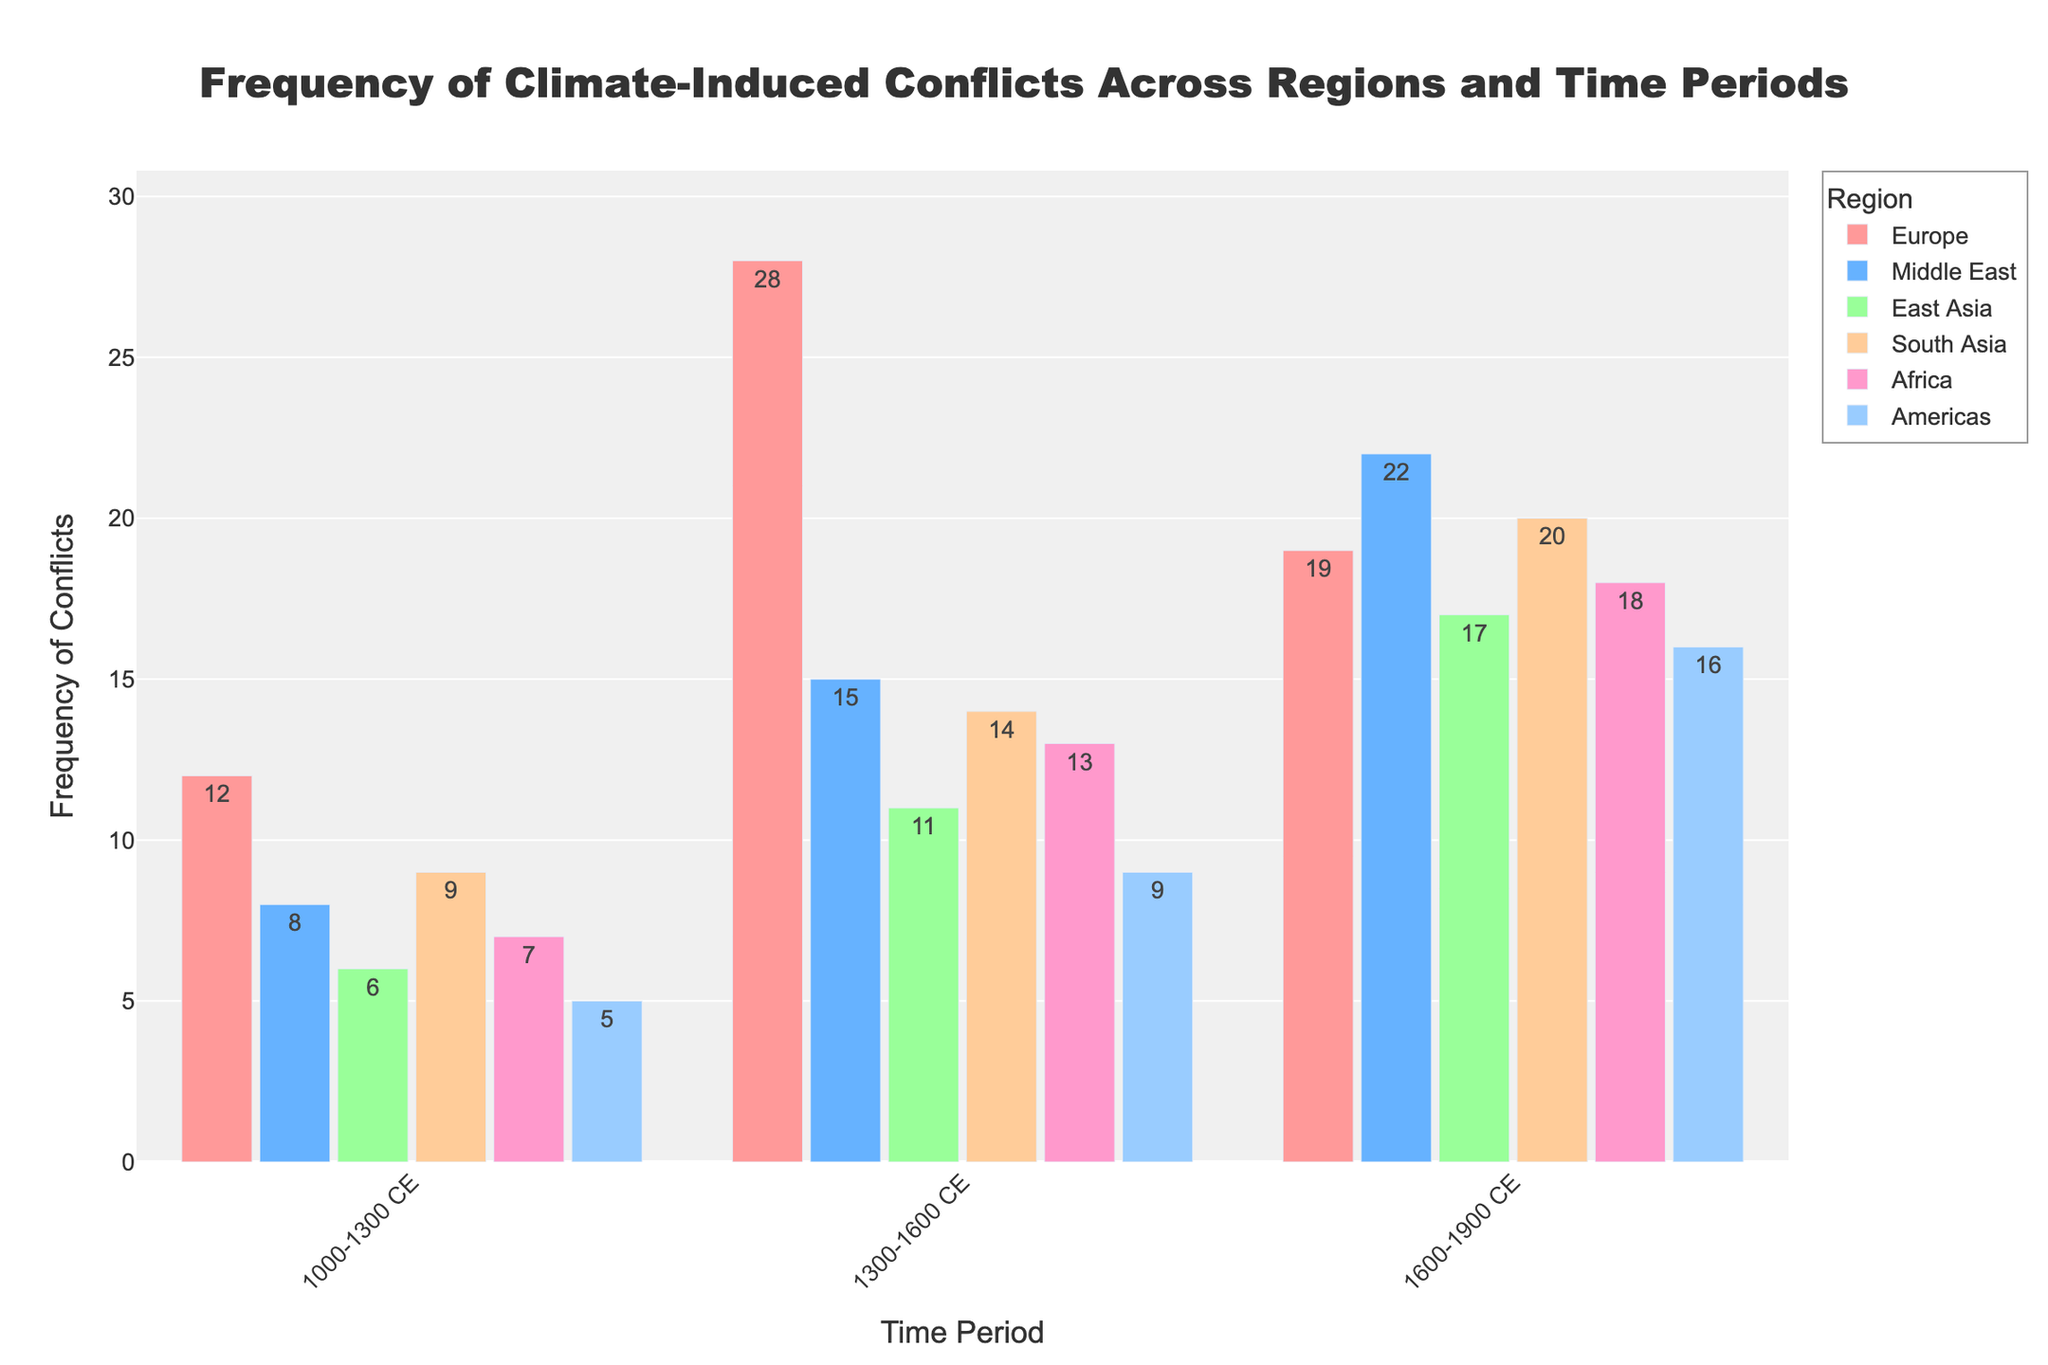What's the total frequency of climate-induced conflicts in Europe across all time periods? Sum the values of Europe for all time periods: 12 + 28 + 19 = 59.
Answer: 59 Which region saw the highest increase in conflicts from 1000-1300 CE to 1300-1600 CE? Calculate the increase for each region: Europe (28 - 12 = 16), Middle East (15 - 8 = 7), East Asia (11 - 6 = 5), South Asia (14 - 9 = 5), Africa (13 - 7 = 6), Americas (9 - 5 = 4). Europe had the highest increase of 16.
Answer: Europe Which region had the lowest frequency of climate-induced conflicts in the 1000-1300 CE period? Compare the frequencies across regions for 1000-1300 CE: Europe (12), Middle East (8), East Asia (6), South Asia (9), Africa (7), Americas (5). The Americas had the lowest frequency with 5.
Answer: Americas Is the frequency of conflicts in South Asia in the period 1600-1900 CE greater than in East Asia in the same period? Compare the frequencies: South Asia (20) and East Asia (17). South Asia's frequency is greater.
Answer: Yes What's the difference in the frequency of conflicts between Africa and the Americas in the period 1600-1900 CE? Subtract the frequency of the Americas from that of Africa for 1600-1900 CE: 18 - 16 = 2.
Answer: 2 Which time period in East Asia shows the most significant increase in conflicts compared to the previous period? Calculate the changes: 1300-1600 CE (11 - 6 = 5), 1600-1900 CE (17 - 11 = 6). The increase from 1300-1600 CE to 1600-1900 CE is the most significant with 6.
Answer: 1600-1900 CE Did the Middle East experience a greater increase in conflicts from 1300-1600 CE to 1600-1900 CE compared to South Asia during the same periods? Calculate the increase for both regions: Middle East (22 - 15 = 7), South Asia (20 - 14 = 6). The Middle East experienced a greater increase of 7 compared to South Asia's 6.
Answer: Yes Which region has the most similar frequency of conflicts to Middle East during the time period 1300-1600 CE? Compare Middle East's frequency (15) with other regions for 1300-1600 CE: Europe (28), East Asia (11), South Asia (14), Africa (13), Americas (9). South Asia has the most similar frequency with 14.
Answer: South Asia 